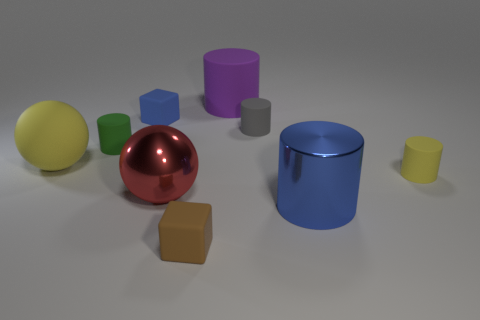There is a tiny thing that is the same color as the shiny cylinder; what material is it?
Give a very brief answer. Rubber. What shape is the small object that is both left of the blue metal object and in front of the green thing?
Offer a very short reply. Cube. Is the number of spheres greater than the number of big red shiny cylinders?
Give a very brief answer. Yes. What material is the gray object?
Give a very brief answer. Rubber. There is another thing that is the same shape as the red object; what size is it?
Provide a succinct answer. Large. Are there any rubber objects in front of the big ball that is right of the tiny blue object?
Make the answer very short. Yes. How many other things are there of the same shape as the gray matte object?
Offer a terse response. 4. Are there more big spheres that are in front of the big matte ball than small green objects right of the tiny blue thing?
Give a very brief answer. Yes. There is a cylinder in front of the small yellow matte object; is its size the same as the block on the left side of the metal ball?
Your answer should be compact. No. The blue matte object has what shape?
Make the answer very short. Cube. 